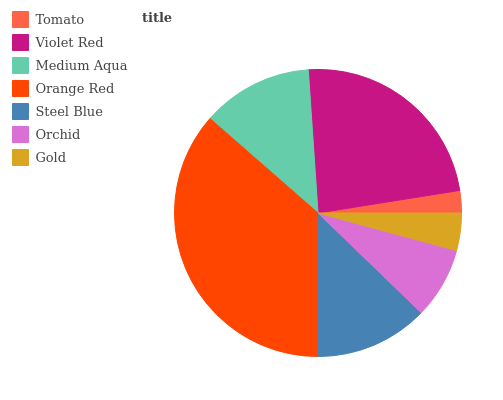Is Tomato the minimum?
Answer yes or no. Yes. Is Orange Red the maximum?
Answer yes or no. Yes. Is Violet Red the minimum?
Answer yes or no. No. Is Violet Red the maximum?
Answer yes or no. No. Is Violet Red greater than Tomato?
Answer yes or no. Yes. Is Tomato less than Violet Red?
Answer yes or no. Yes. Is Tomato greater than Violet Red?
Answer yes or no. No. Is Violet Red less than Tomato?
Answer yes or no. No. Is Medium Aqua the high median?
Answer yes or no. Yes. Is Medium Aqua the low median?
Answer yes or no. Yes. Is Gold the high median?
Answer yes or no. No. Is Orchid the low median?
Answer yes or no. No. 